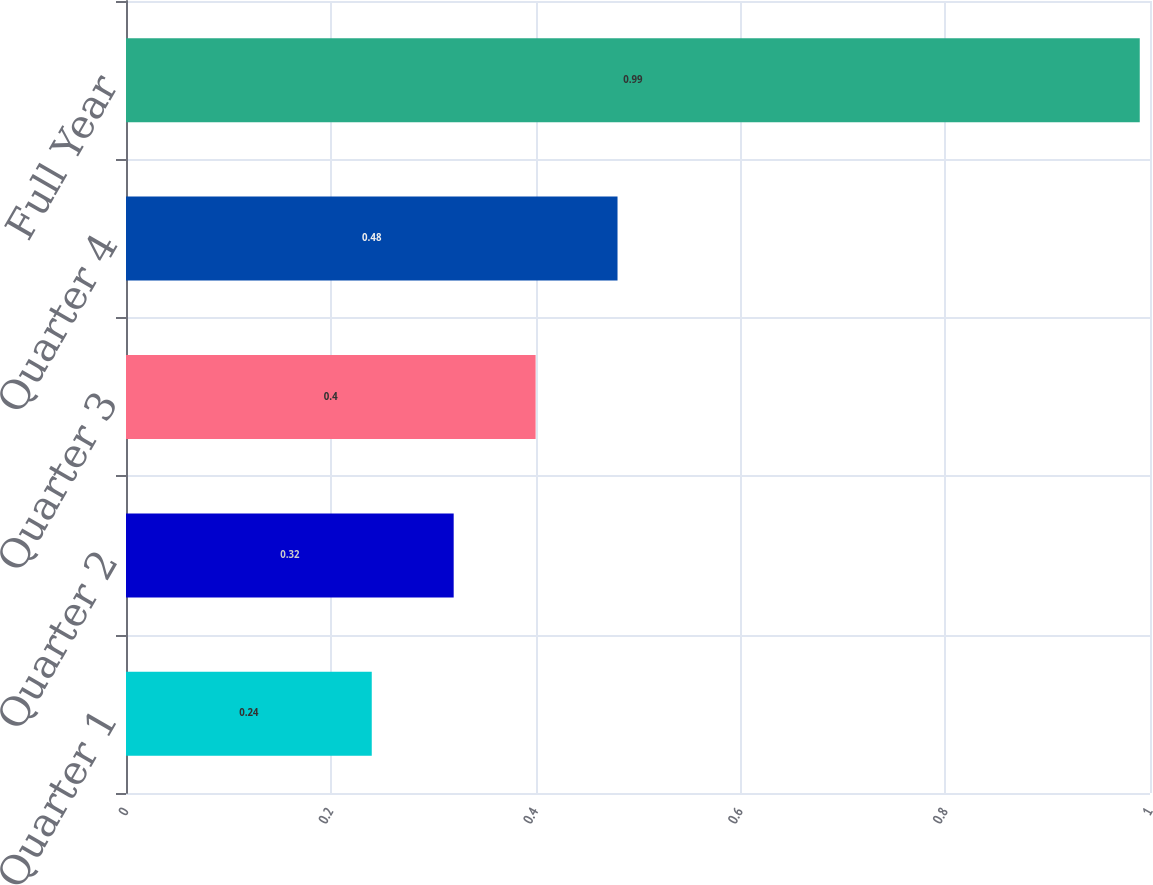Convert chart. <chart><loc_0><loc_0><loc_500><loc_500><bar_chart><fcel>Quarter 1<fcel>Quarter 2<fcel>Quarter 3<fcel>Quarter 4<fcel>Full Year<nl><fcel>0.24<fcel>0.32<fcel>0.4<fcel>0.48<fcel>0.99<nl></chart> 